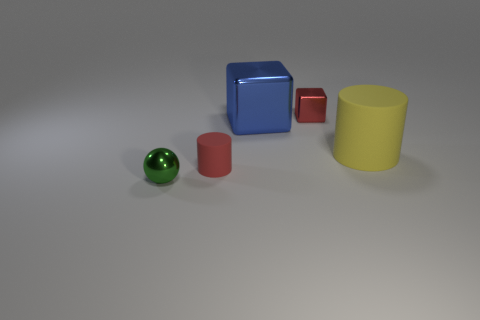Subtract 1 balls. How many balls are left? 0 Add 4 big yellow matte objects. How many objects exist? 9 Subtract all blue blocks. How many blocks are left? 1 Subtract all balls. How many objects are left? 4 Subtract all gray cubes. Subtract all brown spheres. How many cubes are left? 2 Subtract all red blocks. How many purple cylinders are left? 0 Subtract all tiny purple objects. Subtract all blue shiny objects. How many objects are left? 4 Add 1 big yellow cylinders. How many big yellow cylinders are left? 2 Add 4 matte objects. How many matte objects exist? 6 Subtract 0 cyan spheres. How many objects are left? 5 